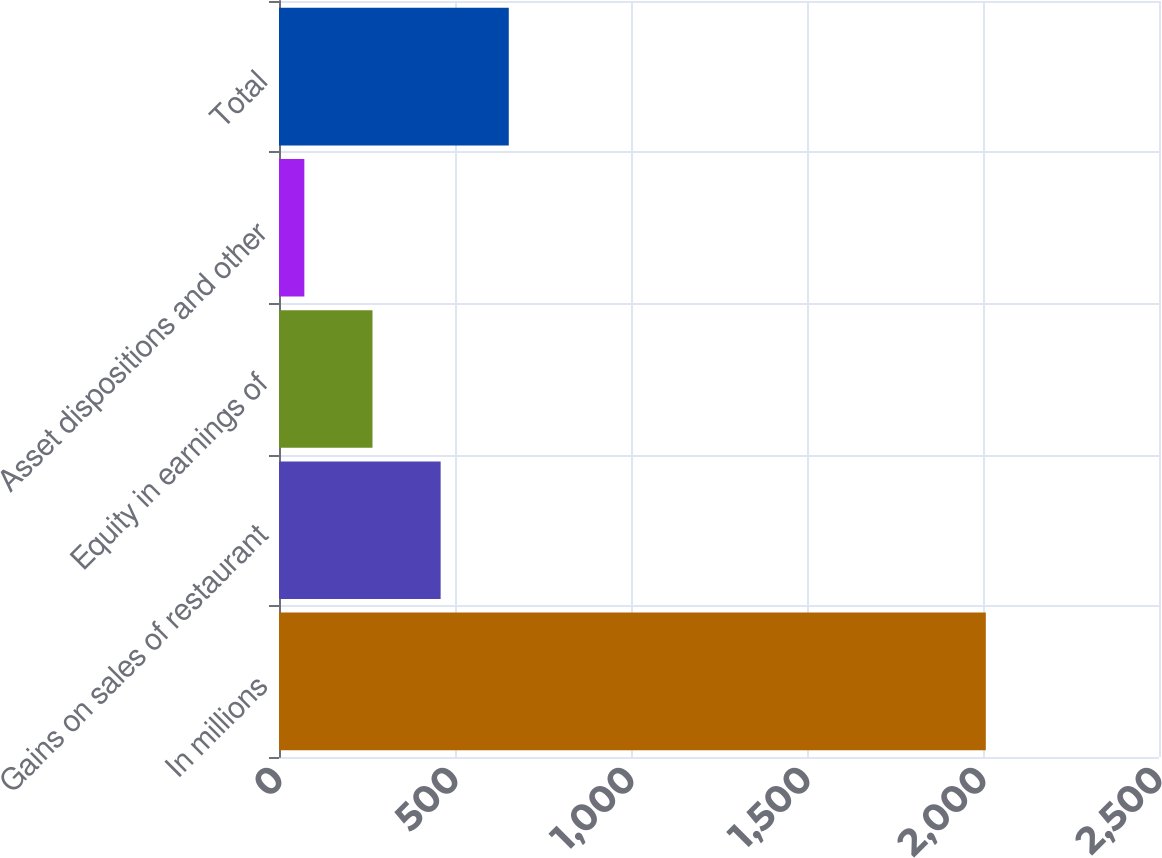Convert chart. <chart><loc_0><loc_0><loc_500><loc_500><bar_chart><fcel>In millions<fcel>Gains on sales of restaurant<fcel>Equity in earnings of<fcel>Asset dispositions and other<fcel>Total<nl><fcel>2008<fcel>459.2<fcel>265.6<fcel>72<fcel>652.8<nl></chart> 